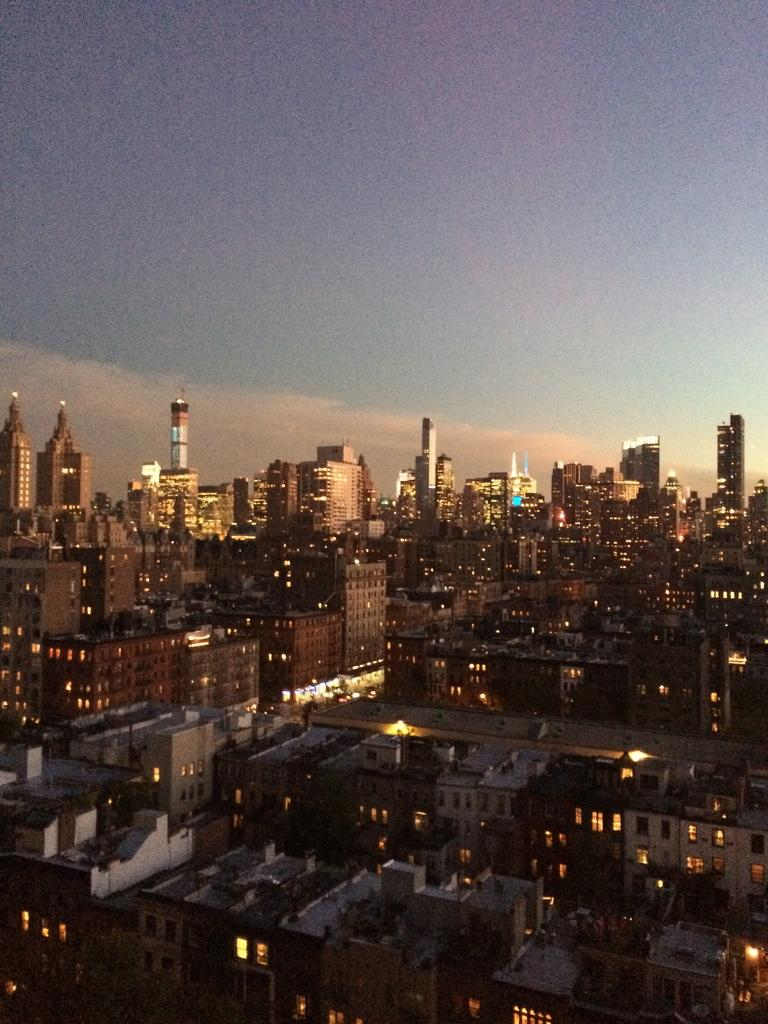What type of structures can be seen in the image? There are buildings in the image. What else is visible in the image besides the buildings? There are lights and other objects in the image. How would you describe the sky in the image? The sky is cloudy in the image. Can you tell me how many shoes are visible in the image? There is no mention of shoes in the image, so it is not possible to determine how many are visible. 